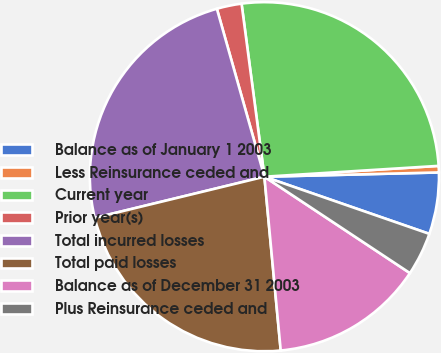Convert chart. <chart><loc_0><loc_0><loc_500><loc_500><pie_chart><fcel>Balance as of January 1 2003<fcel>Less Reinsurance ceded and<fcel>Current year<fcel>Prior year(s)<fcel>Total incurred losses<fcel>Total paid losses<fcel>Balance as of December 31 2003<fcel>Plus Reinsurance ceded and<nl><fcel>5.7%<fcel>0.6%<fcel>26.1%<fcel>2.3%<fcel>24.4%<fcel>22.7%<fcel>14.2%<fcel>4.0%<nl></chart> 